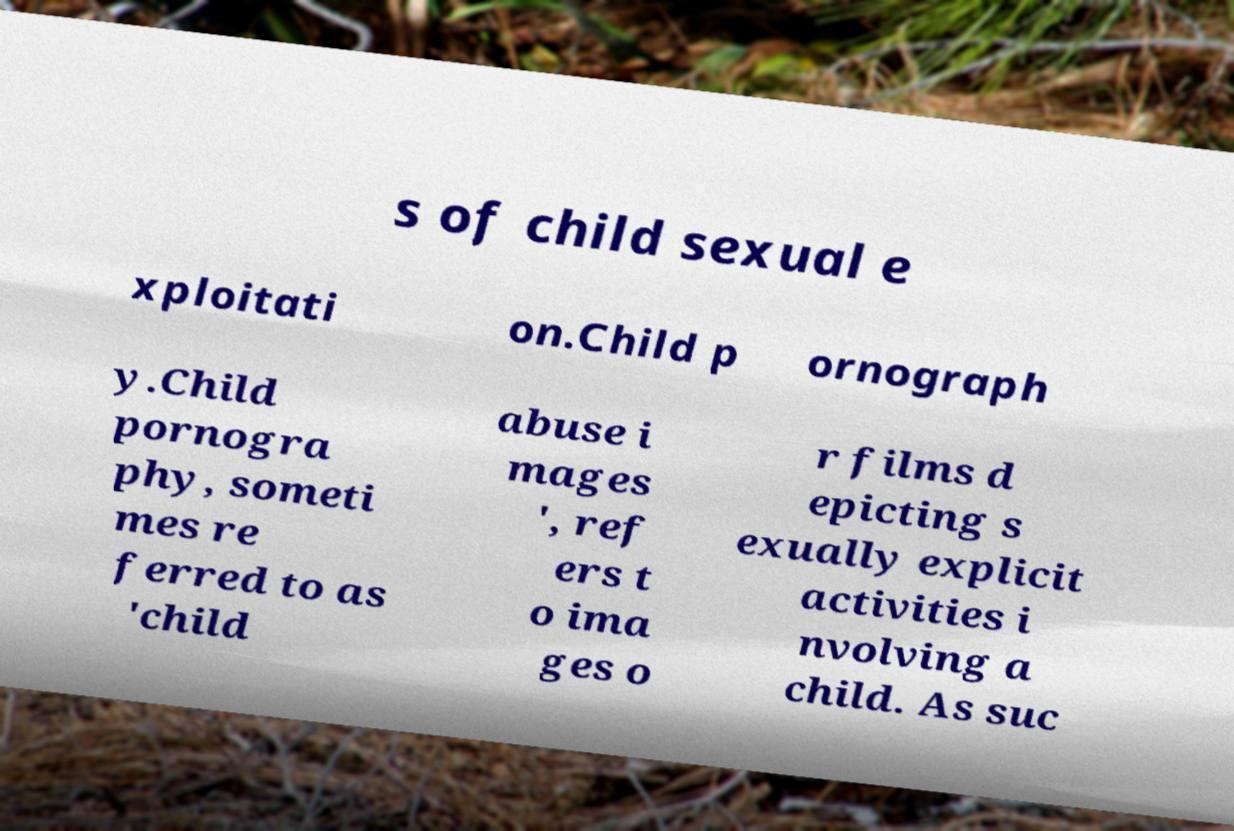What messages or text are displayed in this image? I need them in a readable, typed format. s of child sexual e xploitati on.Child p ornograph y.Child pornogra phy, someti mes re ferred to as 'child abuse i mages ', ref ers t o ima ges o r films d epicting s exually explicit activities i nvolving a child. As suc 